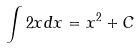Convert formula to latex. <formula><loc_0><loc_0><loc_500><loc_500>\int 2 x d x = x ^ { 2 } + C</formula> 